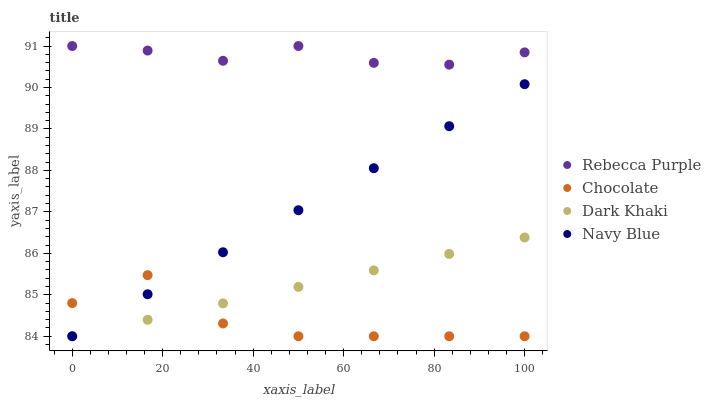Does Chocolate have the minimum area under the curve?
Answer yes or no. Yes. Does Rebecca Purple have the maximum area under the curve?
Answer yes or no. Yes. Does Navy Blue have the minimum area under the curve?
Answer yes or no. No. Does Navy Blue have the maximum area under the curve?
Answer yes or no. No. Is Navy Blue the smoothest?
Answer yes or no. Yes. Is Chocolate the roughest?
Answer yes or no. Yes. Is Rebecca Purple the smoothest?
Answer yes or no. No. Is Rebecca Purple the roughest?
Answer yes or no. No. Does Dark Khaki have the lowest value?
Answer yes or no. Yes. Does Rebecca Purple have the lowest value?
Answer yes or no. No. Does Rebecca Purple have the highest value?
Answer yes or no. Yes. Does Navy Blue have the highest value?
Answer yes or no. No. Is Dark Khaki less than Rebecca Purple?
Answer yes or no. Yes. Is Rebecca Purple greater than Chocolate?
Answer yes or no. Yes. Does Navy Blue intersect Dark Khaki?
Answer yes or no. Yes. Is Navy Blue less than Dark Khaki?
Answer yes or no. No. Is Navy Blue greater than Dark Khaki?
Answer yes or no. No. Does Dark Khaki intersect Rebecca Purple?
Answer yes or no. No. 